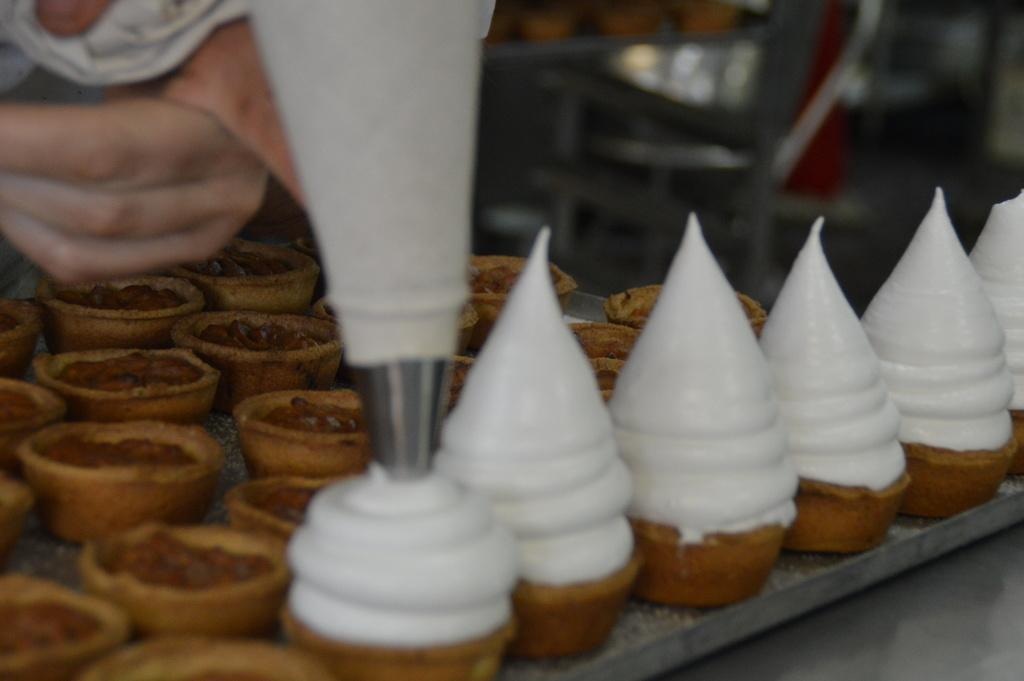Can you describe this image briefly? In this picture we can see ice creams and cups. 